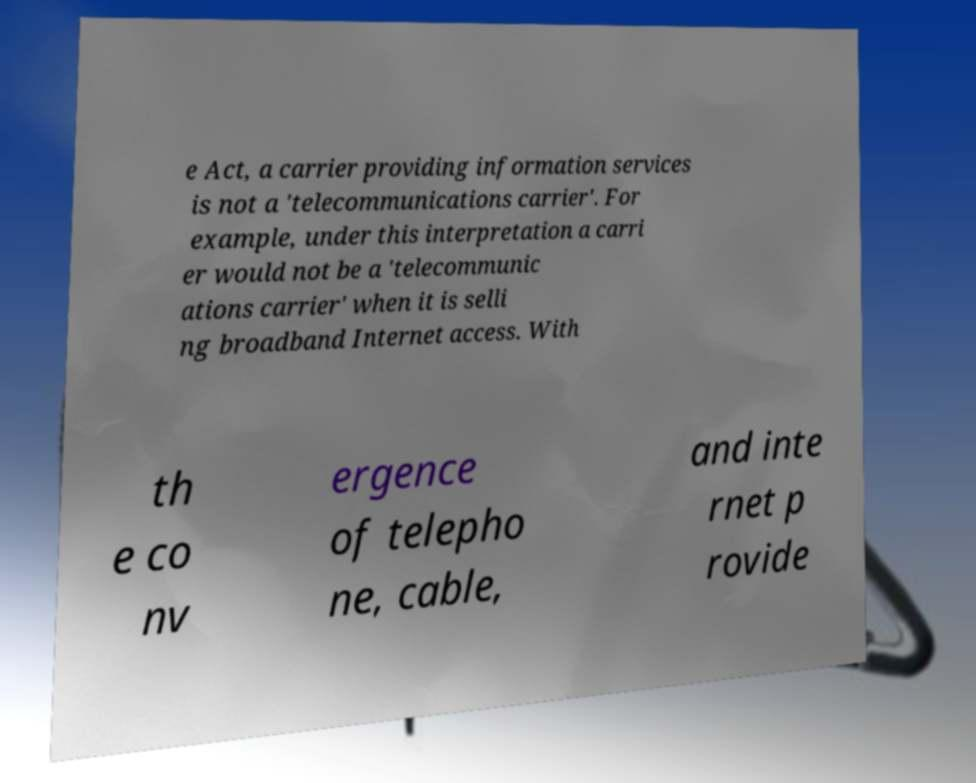What messages or text are displayed in this image? I need them in a readable, typed format. e Act, a carrier providing information services is not a 'telecommunications carrier'. For example, under this interpretation a carri er would not be a 'telecommunic ations carrier' when it is selli ng broadband Internet access. With th e co nv ergence of telepho ne, cable, and inte rnet p rovide 